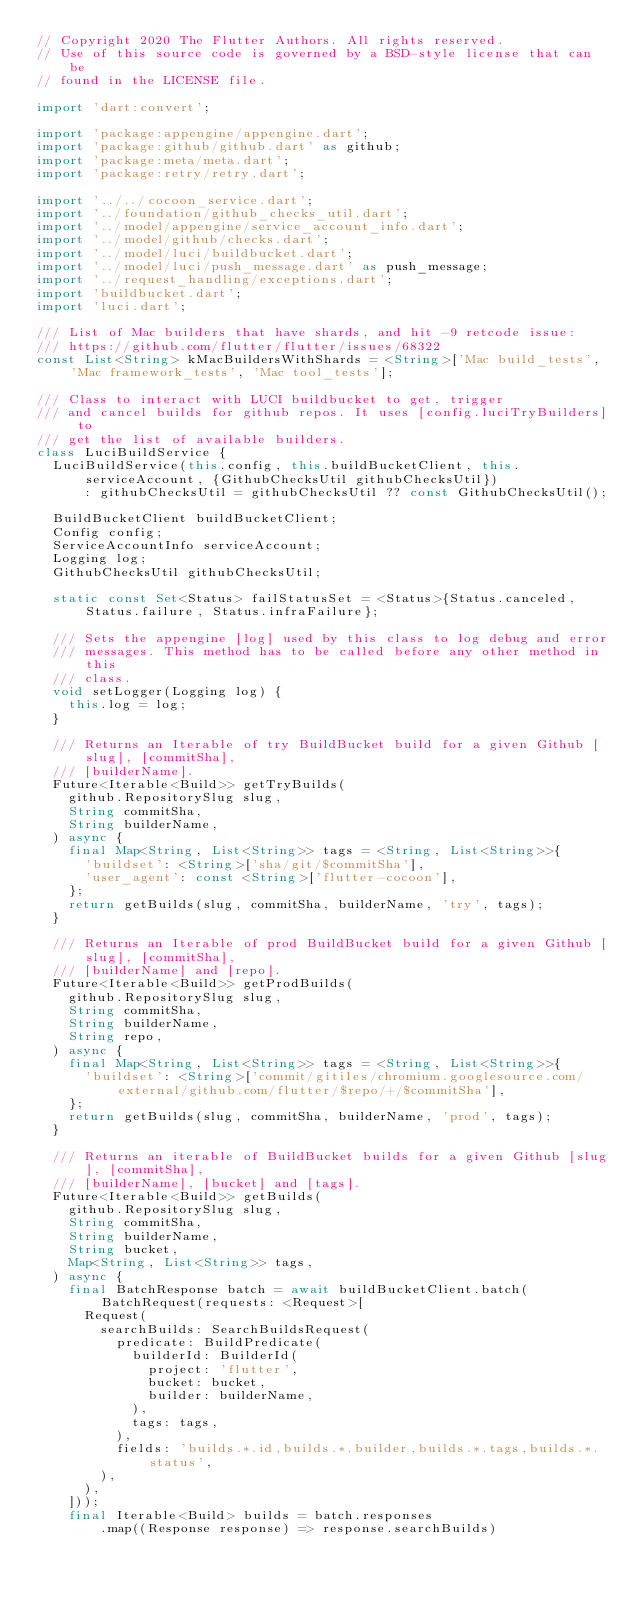<code> <loc_0><loc_0><loc_500><loc_500><_Dart_>// Copyright 2020 The Flutter Authors. All rights reserved.
// Use of this source code is governed by a BSD-style license that can be
// found in the LICENSE file.

import 'dart:convert';

import 'package:appengine/appengine.dart';
import 'package:github/github.dart' as github;
import 'package:meta/meta.dart';
import 'package:retry/retry.dart';

import '../../cocoon_service.dart';
import '../foundation/github_checks_util.dart';
import '../model/appengine/service_account_info.dart';
import '../model/github/checks.dart';
import '../model/luci/buildbucket.dart';
import '../model/luci/push_message.dart' as push_message;
import '../request_handling/exceptions.dart';
import 'buildbucket.dart';
import 'luci.dart';

/// List of Mac builders that have shards, and hit -9 retcode issue:
/// https://github.com/flutter/flutter/issues/68322
const List<String> kMacBuildersWithShards = <String>['Mac build_tests', 'Mac framework_tests', 'Mac tool_tests'];

/// Class to interact with LUCI buildbucket to get, trigger
/// and cancel builds for github repos. It uses [config.luciTryBuilders] to
/// get the list of available builders.
class LuciBuildService {
  LuciBuildService(this.config, this.buildBucketClient, this.serviceAccount, {GithubChecksUtil githubChecksUtil})
      : githubChecksUtil = githubChecksUtil ?? const GithubChecksUtil();

  BuildBucketClient buildBucketClient;
  Config config;
  ServiceAccountInfo serviceAccount;
  Logging log;
  GithubChecksUtil githubChecksUtil;

  static const Set<Status> failStatusSet = <Status>{Status.canceled, Status.failure, Status.infraFailure};

  /// Sets the appengine [log] used by this class to log debug and error
  /// messages. This method has to be called before any other method in this
  /// class.
  void setLogger(Logging log) {
    this.log = log;
  }

  /// Returns an Iterable of try BuildBucket build for a given Github [slug], [commitSha],
  /// [builderName].
  Future<Iterable<Build>> getTryBuilds(
    github.RepositorySlug slug,
    String commitSha,
    String builderName,
  ) async {
    final Map<String, List<String>> tags = <String, List<String>>{
      'buildset': <String>['sha/git/$commitSha'],
      'user_agent': const <String>['flutter-cocoon'],
    };
    return getBuilds(slug, commitSha, builderName, 'try', tags);
  }

  /// Returns an Iterable of prod BuildBucket build for a given Github [slug], [commitSha],
  /// [builderName] and [repo].
  Future<Iterable<Build>> getProdBuilds(
    github.RepositorySlug slug,
    String commitSha,
    String builderName,
    String repo,
  ) async {
    final Map<String, List<String>> tags = <String, List<String>>{
      'buildset': <String>['commit/gitiles/chromium.googlesource.com/external/github.com/flutter/$repo/+/$commitSha'],
    };
    return getBuilds(slug, commitSha, builderName, 'prod', tags);
  }

  /// Returns an iterable of BuildBucket builds for a given Github [slug], [commitSha],
  /// [builderName], [bucket] and [tags].
  Future<Iterable<Build>> getBuilds(
    github.RepositorySlug slug,
    String commitSha,
    String builderName,
    String bucket,
    Map<String, List<String>> tags,
  ) async {
    final BatchResponse batch = await buildBucketClient.batch(BatchRequest(requests: <Request>[
      Request(
        searchBuilds: SearchBuildsRequest(
          predicate: BuildPredicate(
            builderId: BuilderId(
              project: 'flutter',
              bucket: bucket,
              builder: builderName,
            ),
            tags: tags,
          ),
          fields: 'builds.*.id,builds.*.builder,builds.*.tags,builds.*.status',
        ),
      ),
    ]));
    final Iterable<Build> builds = batch.responses
        .map((Response response) => response.searchBuilds)</code> 